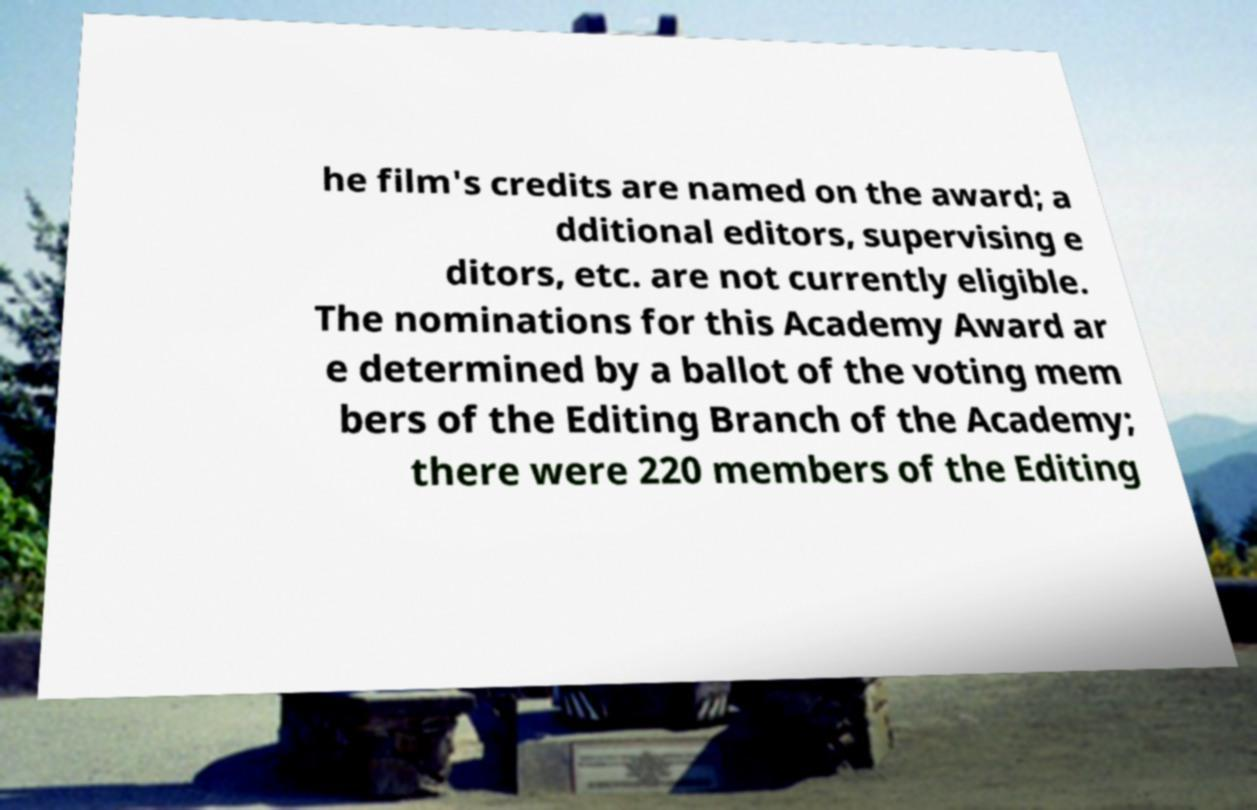There's text embedded in this image that I need extracted. Can you transcribe it verbatim? he film's credits are named on the award; a dditional editors, supervising e ditors, etc. are not currently eligible. The nominations for this Academy Award ar e determined by a ballot of the voting mem bers of the Editing Branch of the Academy; there were 220 members of the Editing 